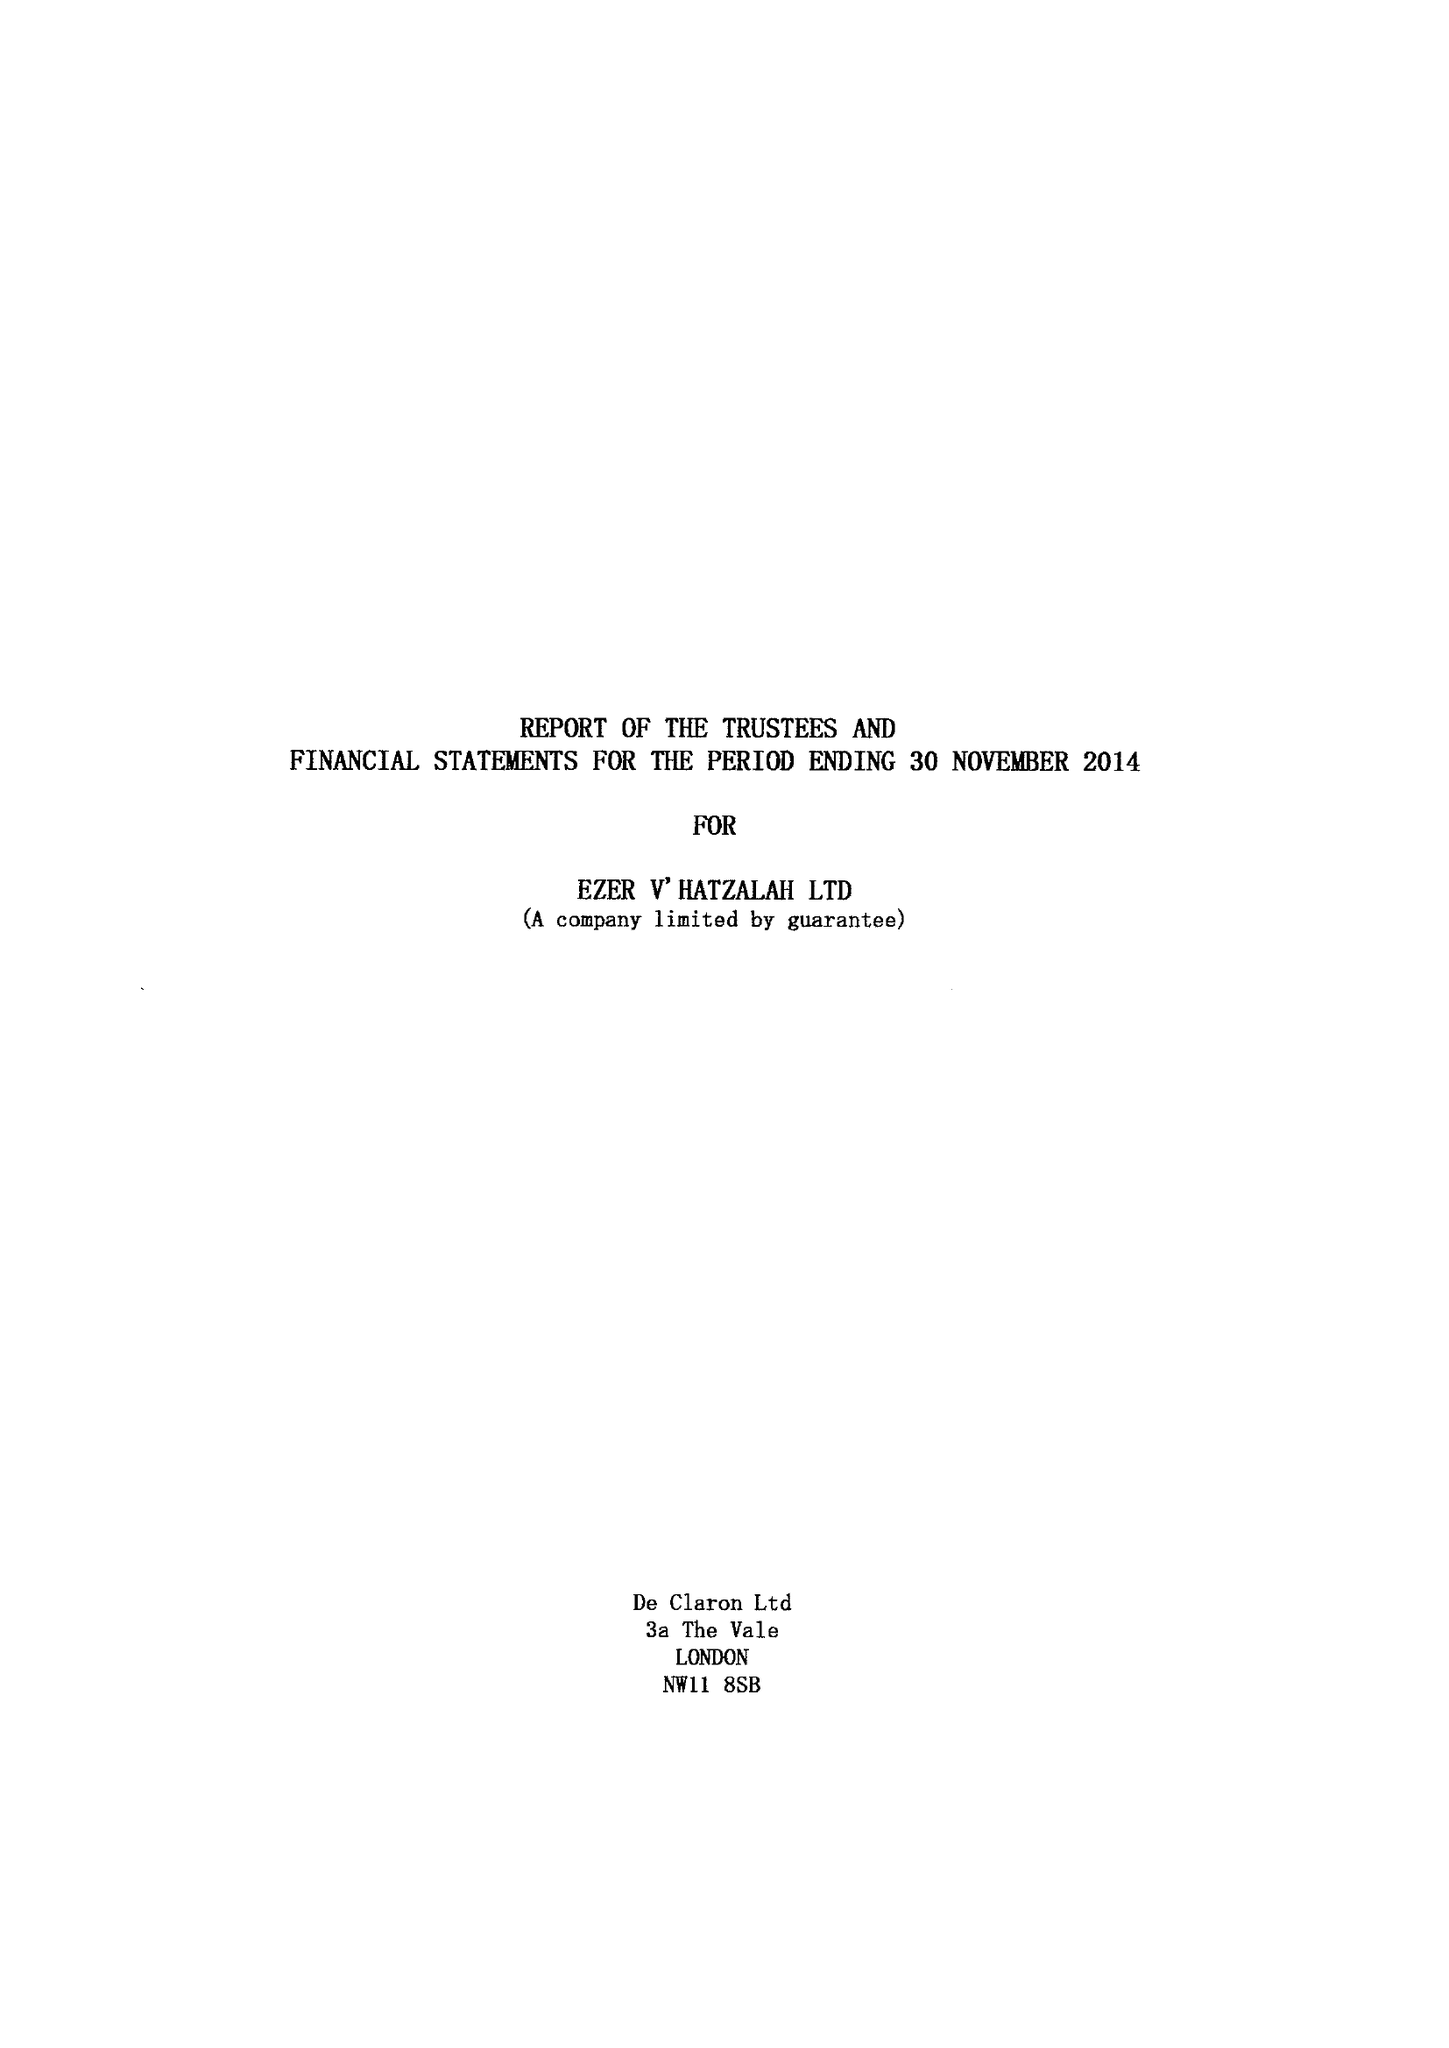What is the value for the address__postcode?
Answer the question using a single word or phrase. N16 5PZ 